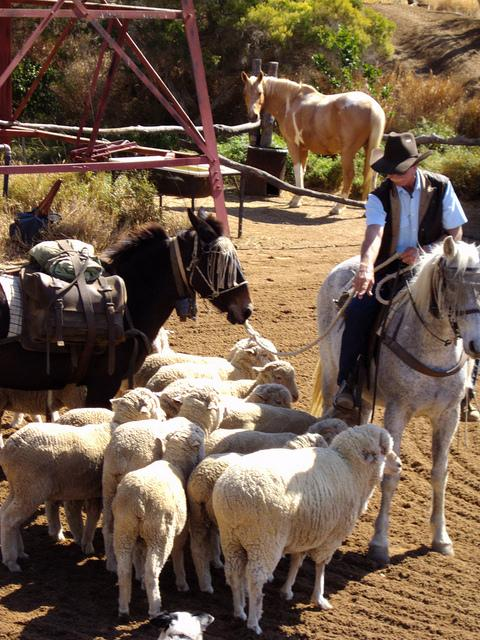What other animal could help here? dog 